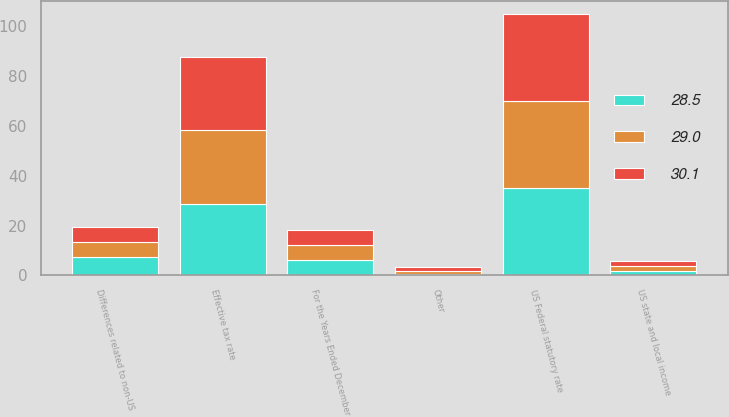Convert chart to OTSL. <chart><loc_0><loc_0><loc_500><loc_500><stacked_bar_chart><ecel><fcel>For the Years Ended December<fcel>US Federal statutory rate<fcel>US state and local income<fcel>Differences related to non-US<fcel>Other<fcel>Effective tax rate<nl><fcel>28.5<fcel>6.1<fcel>35<fcel>1.7<fcel>7.5<fcel>0.7<fcel>28.5<nl><fcel>29<fcel>6.1<fcel>35<fcel>2.1<fcel>6<fcel>1<fcel>30.1<nl><fcel>30.1<fcel>6.1<fcel>35<fcel>1.9<fcel>6.1<fcel>1.8<fcel>29<nl></chart> 